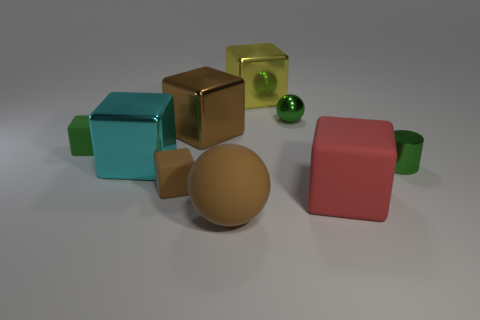Subtract all green spheres. How many brown blocks are left? 2 Add 1 small metal cylinders. How many objects exist? 10 Subtract all small cubes. How many cubes are left? 4 Subtract 2 blocks. How many blocks are left? 4 Subtract all brown blocks. How many blocks are left? 4 Subtract all balls. How many objects are left? 7 Add 8 tiny metal things. How many tiny metal things exist? 10 Subtract 0 gray blocks. How many objects are left? 9 Subtract all blue balls. Subtract all purple cubes. How many balls are left? 2 Subtract all cyan things. Subtract all tiny cyan rubber cylinders. How many objects are left? 8 